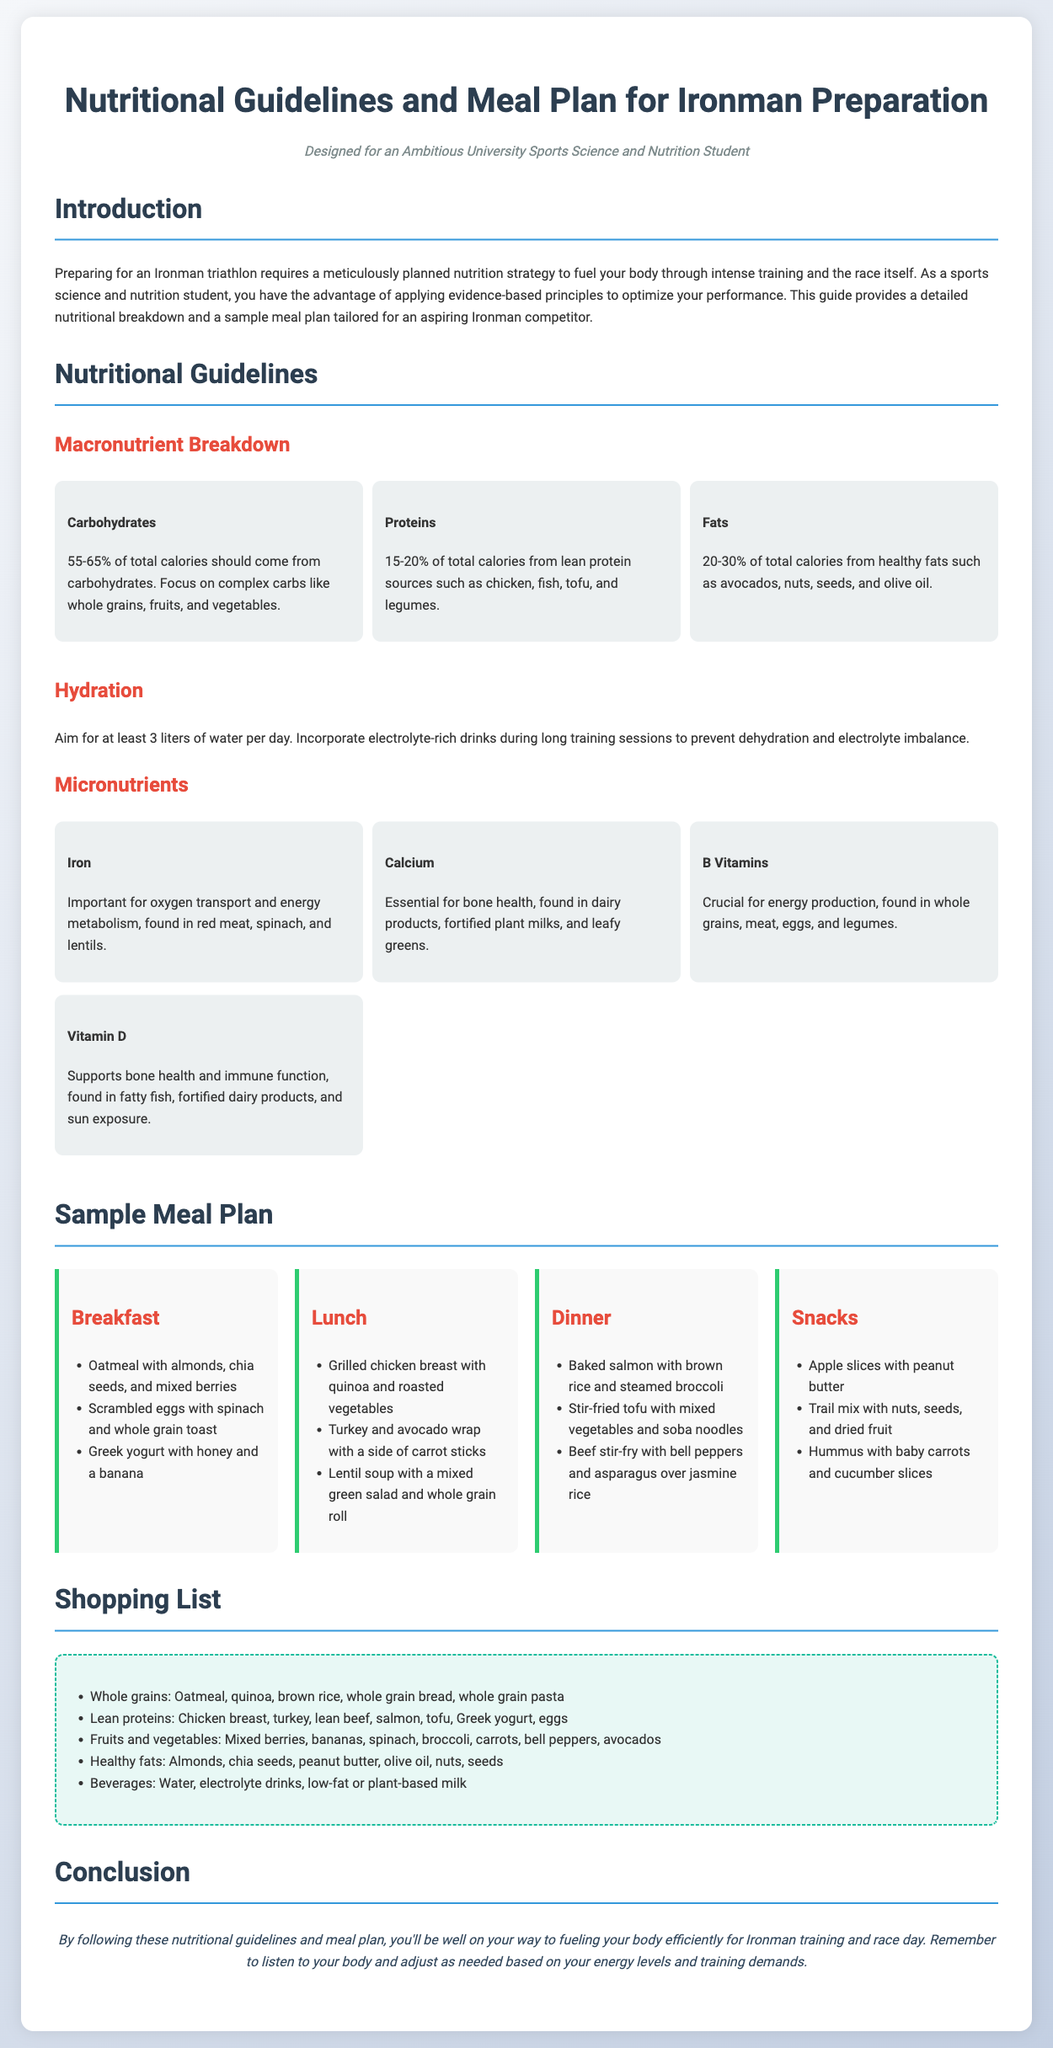What percentage of total calories should come from carbohydrates? The document states that 55-65% of total calories should come from carbohydrates.
Answer: 55-65% What are the three types of macronutrients mentioned? The macronutrients mentioned are carbohydrates, proteins, and fats.
Answer: Carbohydrates, proteins, fats How many liters of water should be consumed daily? The guidelines recommend aiming for at least 3 liters of water per day.
Answer: 3 liters What is the primary protein source listed for lunch? Grilled chicken breast is listed as the primary protein source for lunch.
Answer: Grilled chicken breast Which micronutrient is important for oxygen transport? The document highlights iron as important for oxygen transport and energy metabolism.
Answer: Iron What type of meal is included for breakfast? The sample meal plan includes oatmeal with almonds, chia seeds, and mixed berries for breakfast.
Answer: Oatmeal with almonds, chia seeds, and mixed berries What is a recommended fat source in the diet? Healthy fats such as avocados are recommended in the diet.
Answer: Avocados What type of drink should be incorporated during long training sessions? Electrolyte-rich drinks are recommended during long training sessions to prevent hydration issues.
Answer: Electrolyte-rich drinks What should be included on the shopping list for healthy fats? Almonds, chia seeds, and olive oil are included in the shopping list for healthy fats.
Answer: Almonds, chia seeds, olive oil 